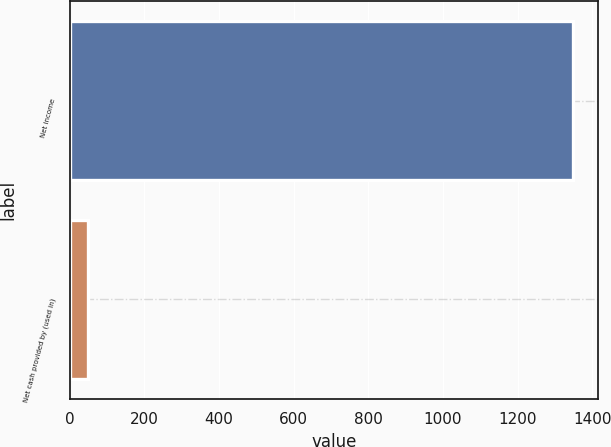Convert chart. <chart><loc_0><loc_0><loc_500><loc_500><bar_chart><fcel>Net income<fcel>Net cash provided by (used in)<nl><fcel>1347<fcel>49<nl></chart> 